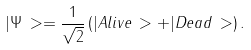<formula> <loc_0><loc_0><loc_500><loc_500>| \Psi \, > = \frac { 1 } { \sqrt { 2 } } \left ( | { A l i v e } \, > + | { D e a d } \, > \right ) .</formula> 